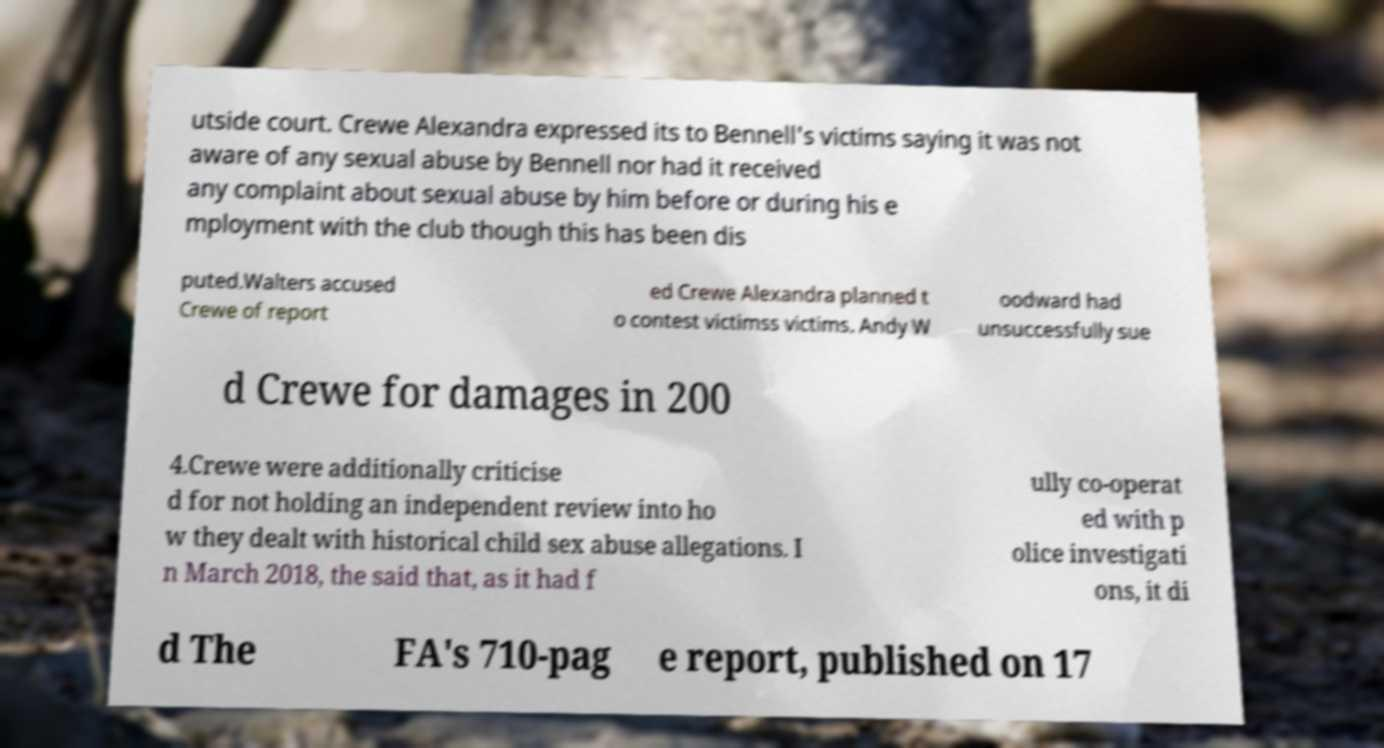For documentation purposes, I need the text within this image transcribed. Could you provide that? utside court. Crewe Alexandra expressed its to Bennell's victims saying it was not aware of any sexual abuse by Bennell nor had it received any complaint about sexual abuse by him before or during his e mployment with the club though this has been dis puted.Walters accused Crewe of report ed Crewe Alexandra planned t o contest victimss victims. Andy W oodward had unsuccessfully sue d Crewe for damages in 200 4.Crewe were additionally criticise d for not holding an independent review into ho w they dealt with historical child sex abuse allegations. I n March 2018, the said that, as it had f ully co-operat ed with p olice investigati ons, it di d The FA's 710-pag e report, published on 17 